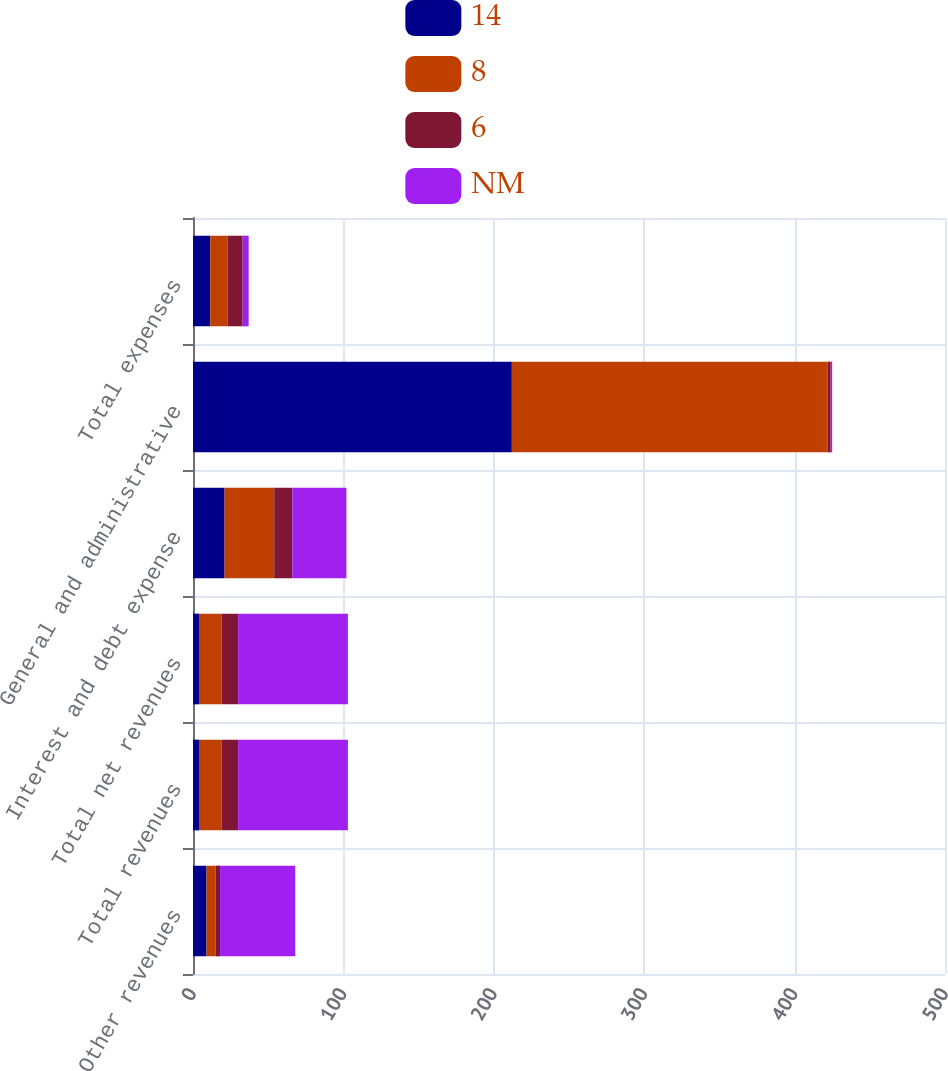Convert chart. <chart><loc_0><loc_0><loc_500><loc_500><stacked_bar_chart><ecel><fcel>Other revenues<fcel>Total revenues<fcel>Total net revenues<fcel>Interest and debt expense<fcel>General and administrative<fcel>Total expenses<nl><fcel>14<fcel>9<fcel>4<fcel>4<fcel>21<fcel>212<fcel>11.5<nl><fcel>8<fcel>6<fcel>15<fcel>15<fcel>33<fcel>210<fcel>11.5<nl><fcel>6<fcel>3<fcel>11<fcel>11<fcel>12<fcel>2<fcel>10<nl><fcel>NM<fcel>50<fcel>73<fcel>73<fcel>36<fcel>1<fcel>4<nl></chart> 